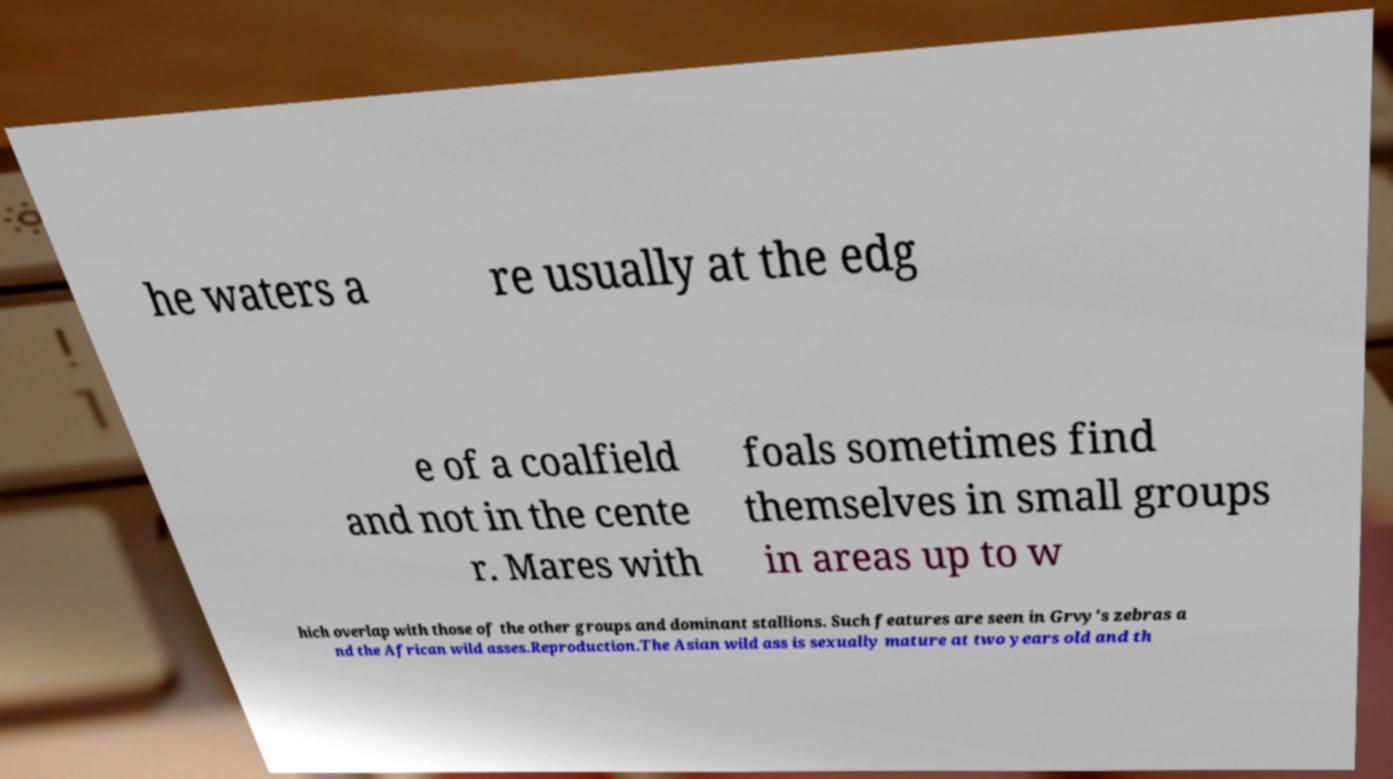Please read and relay the text visible in this image. What does it say? he waters a re usually at the edg e of a coalfield and not in the cente r. Mares with foals sometimes find themselves in small groups in areas up to w hich overlap with those of the other groups and dominant stallions. Such features are seen in Grvy's zebras a nd the African wild asses.Reproduction.The Asian wild ass is sexually mature at two years old and th 